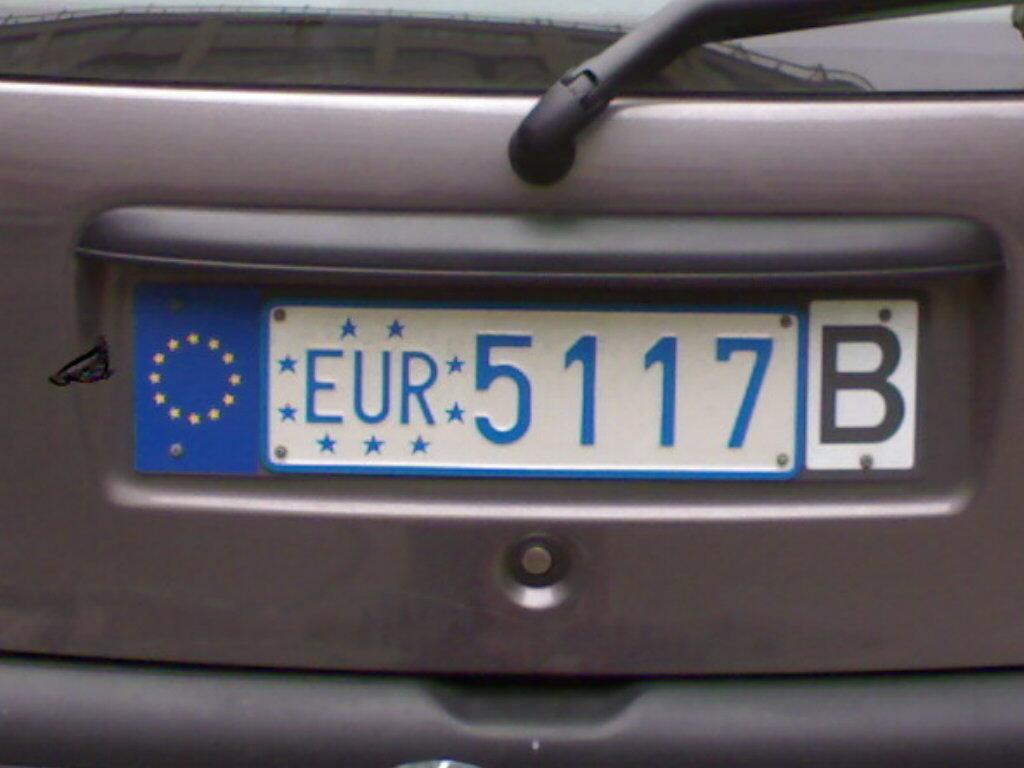Describe this image in one or two sentences. In this image I can see the vehicle with the number plate. 